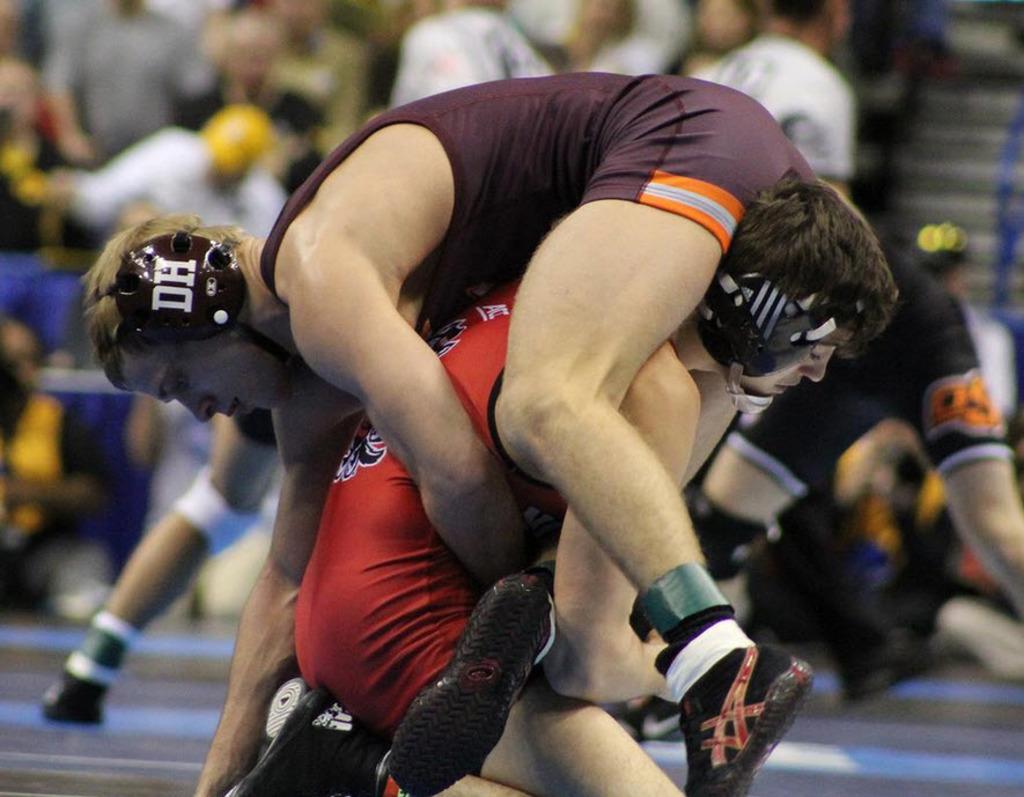What are the letters on the wrestler's ear protection?
Offer a terse response. Dh. 